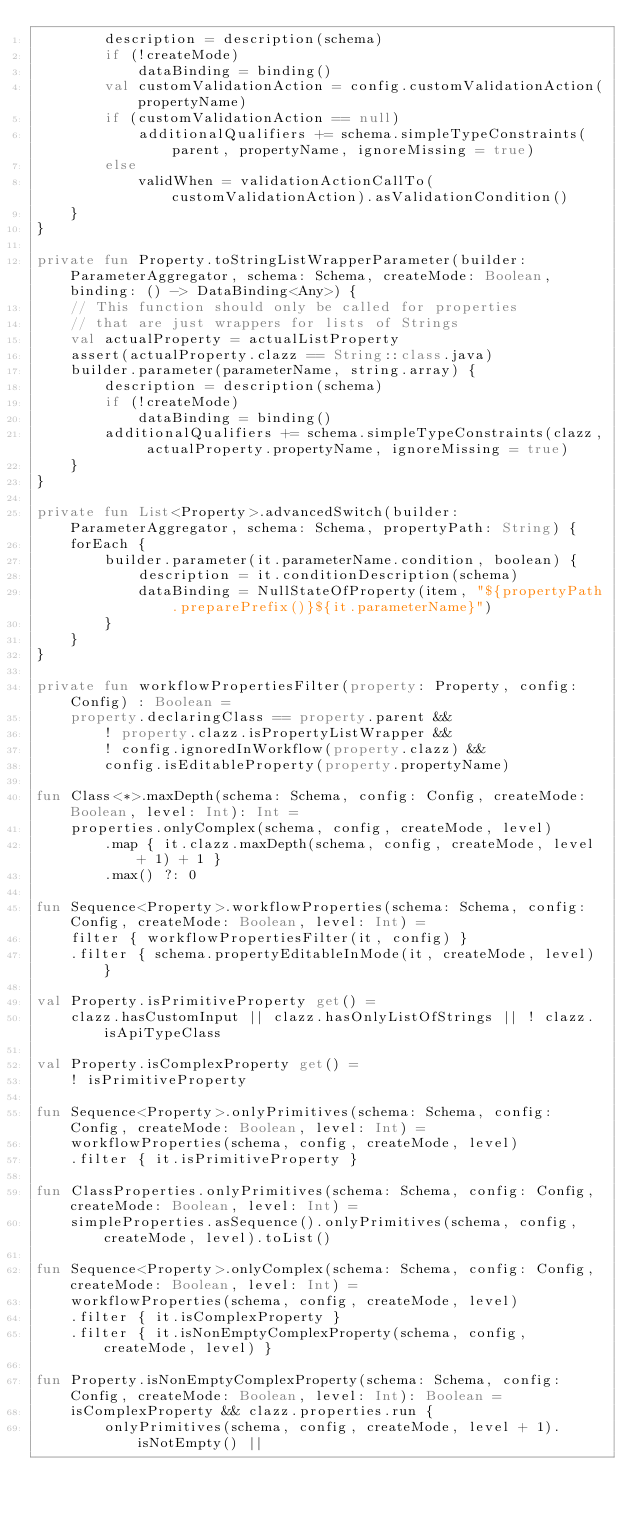Convert code to text. <code><loc_0><loc_0><loc_500><loc_500><_Kotlin_>        description = description(schema)
        if (!createMode)
            dataBinding = binding()
        val customValidationAction = config.customValidationAction(propertyName)
        if (customValidationAction == null)
            additionalQualifiers += schema.simpleTypeConstraints(parent, propertyName, ignoreMissing = true)
        else
            validWhen = validationActionCallTo(customValidationAction).asValidationCondition()
    }
}

private fun Property.toStringListWrapperParameter(builder: ParameterAggregator, schema: Schema, createMode: Boolean, binding: () -> DataBinding<Any>) {
    // This function should only be called for properties
    // that are just wrappers for lists of Strings
    val actualProperty = actualListProperty
    assert(actualProperty.clazz == String::class.java)
    builder.parameter(parameterName, string.array) {
        description = description(schema)
        if (!createMode)
            dataBinding = binding()
        additionalQualifiers += schema.simpleTypeConstraints(clazz, actualProperty.propertyName, ignoreMissing = true)
    }
}

private fun List<Property>.advancedSwitch(builder: ParameterAggregator, schema: Schema, propertyPath: String) {
    forEach {
        builder.parameter(it.parameterName.condition, boolean) {
            description = it.conditionDescription(schema)
            dataBinding = NullStateOfProperty(item, "${propertyPath.preparePrefix()}${it.parameterName}")
        }
    }
}

private fun workflowPropertiesFilter(property: Property, config: Config) : Boolean =
    property.declaringClass == property.parent &&
        ! property.clazz.isPropertyListWrapper &&
        ! config.ignoredInWorkflow(property.clazz) &&
        config.isEditableProperty(property.propertyName)

fun Class<*>.maxDepth(schema: Schema, config: Config, createMode: Boolean, level: Int): Int =
    properties.onlyComplex(schema, config, createMode, level)
        .map { it.clazz.maxDepth(schema, config, createMode, level + 1) + 1 }
        .max() ?: 0

fun Sequence<Property>.workflowProperties(schema: Schema, config: Config, createMode: Boolean, level: Int) =
    filter { workflowPropertiesFilter(it, config) }
    .filter { schema.propertyEditableInMode(it, createMode, level) }

val Property.isPrimitiveProperty get() =
    clazz.hasCustomInput || clazz.hasOnlyListOfStrings || ! clazz.isApiTypeClass

val Property.isComplexProperty get() =
    ! isPrimitiveProperty

fun Sequence<Property>.onlyPrimitives(schema: Schema, config: Config, createMode: Boolean, level: Int) =
    workflowProperties(schema, config, createMode, level)
    .filter { it.isPrimitiveProperty }

fun ClassProperties.onlyPrimitives(schema: Schema, config: Config, createMode: Boolean, level: Int) =
    simpleProperties.asSequence().onlyPrimitives(schema, config, createMode, level).toList()

fun Sequence<Property>.onlyComplex(schema: Schema, config: Config, createMode: Boolean, level: Int) =
    workflowProperties(schema, config, createMode, level)
    .filter { it.isComplexProperty }
    .filter { it.isNonEmptyComplexProperty(schema, config, createMode, level) }

fun Property.isNonEmptyComplexProperty(schema: Schema, config: Config, createMode: Boolean, level: Int): Boolean =
    isComplexProperty && clazz.properties.run {
        onlyPrimitives(schema, config, createMode, level + 1).isNotEmpty() ||</code> 